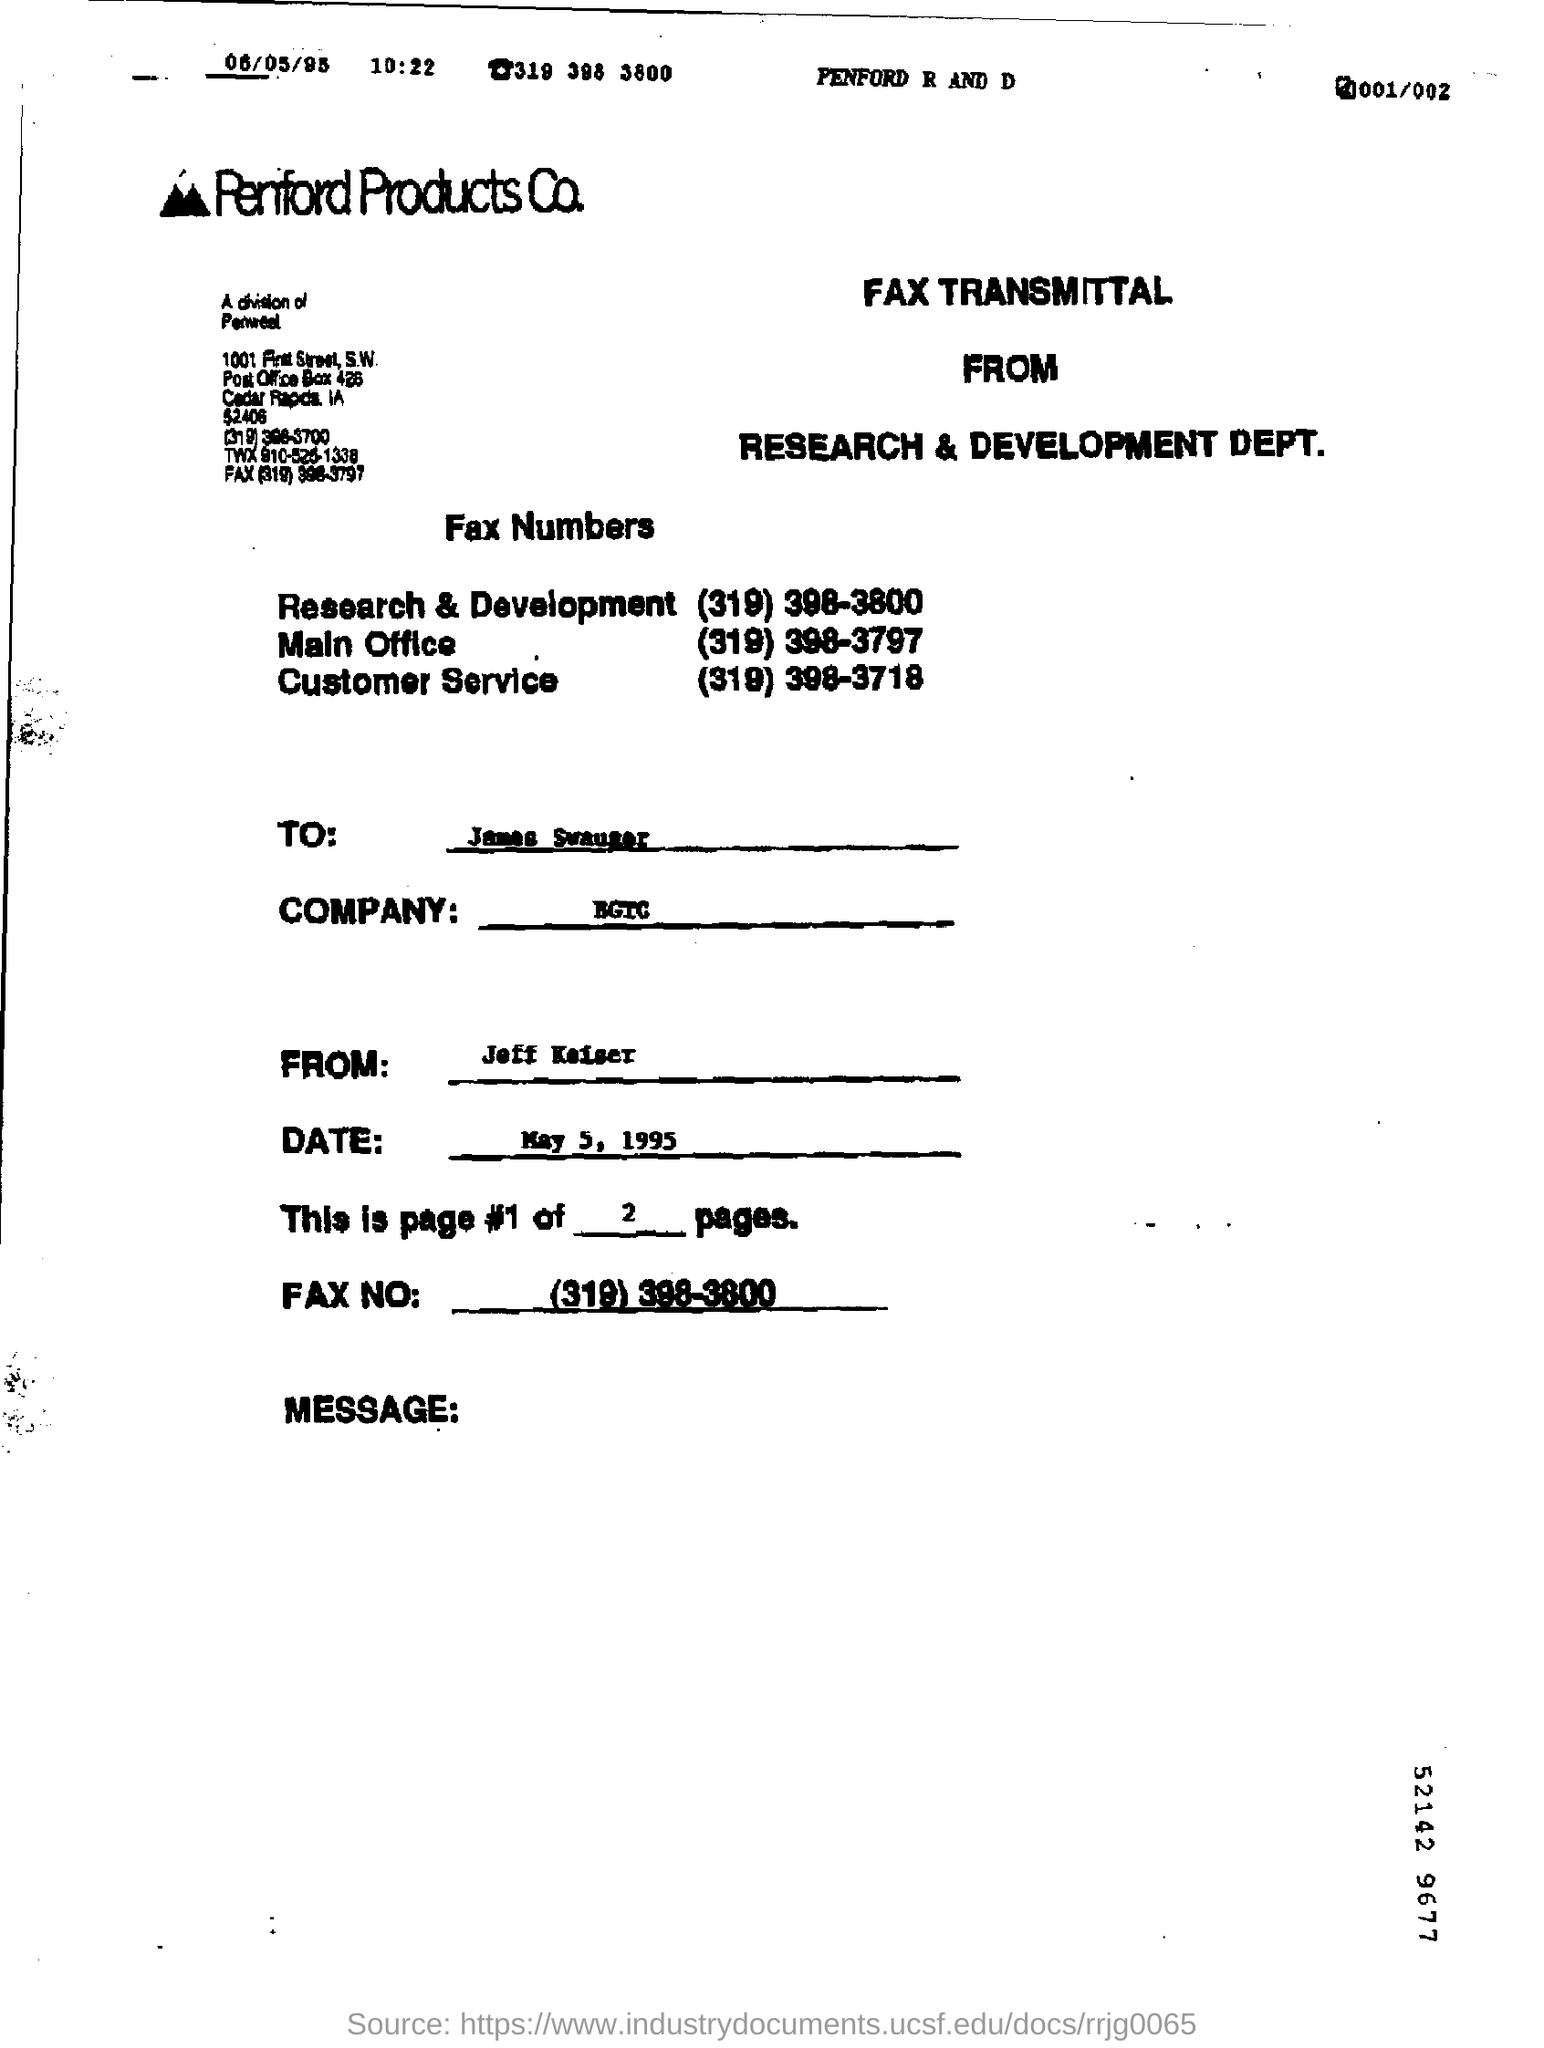What is the fax number of the customer service ?
Give a very brief answer. (319) 398-3718. What is the fax number of the research & development?
Your answer should be very brief. (319) 398-3800. 